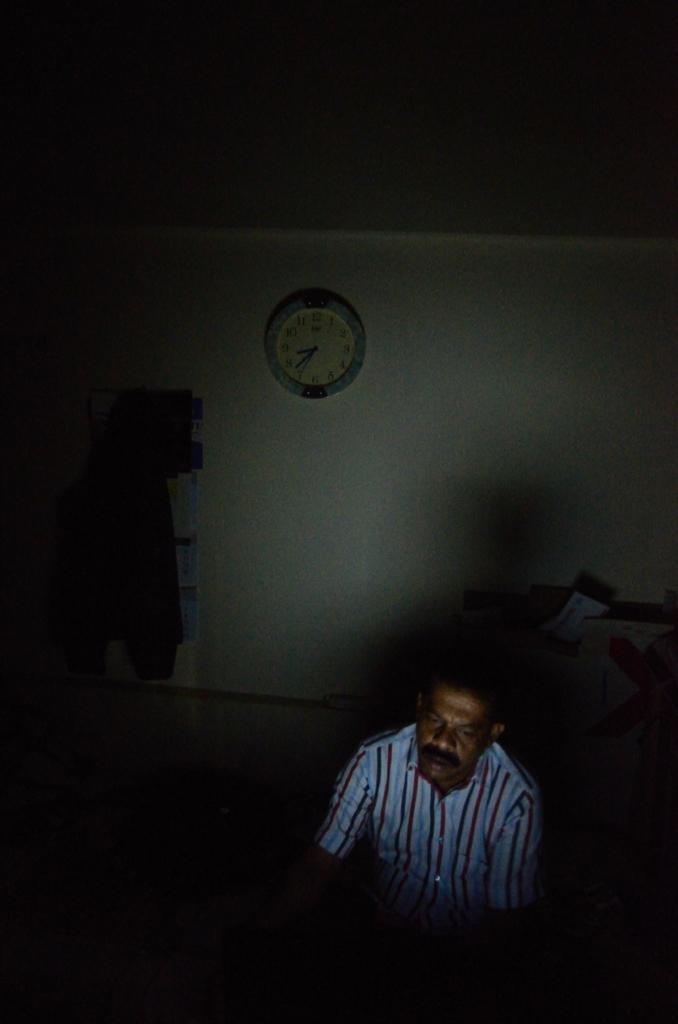In one or two sentences, can you explain what this image depicts? The picture is taken inside a room. In the foreground we can see a person. In the middle there is a wall and a clock. At the top it is dark. 